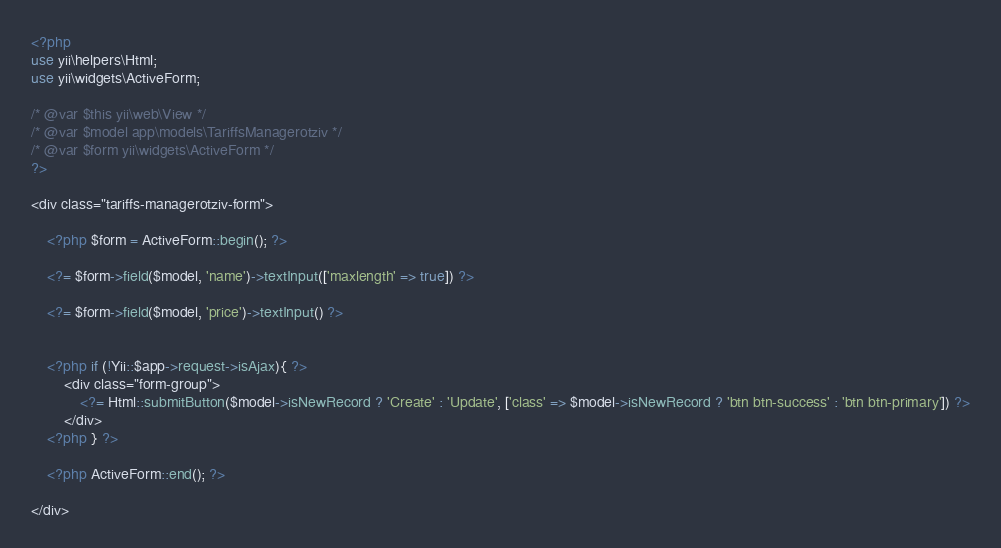Convert code to text. <code><loc_0><loc_0><loc_500><loc_500><_PHP_><?php
use yii\helpers\Html;
use yii\widgets\ActiveForm;

/* @var $this yii\web\View */
/* @var $model app\models\TariffsManagerotziv */
/* @var $form yii\widgets\ActiveForm */
?>

<div class="tariffs-managerotziv-form">

    <?php $form = ActiveForm::begin(); ?>

    <?= $form->field($model, 'name')->textInput(['maxlength' => true]) ?>

    <?= $form->field($model, 'price')->textInput() ?>

  
	<?php if (!Yii::$app->request->isAjax){ ?>
	  	<div class="form-group">
	        <?= Html::submitButton($model->isNewRecord ? 'Create' : 'Update', ['class' => $model->isNewRecord ? 'btn btn-success' : 'btn btn-primary']) ?>
	    </div>
	<?php } ?>

    <?php ActiveForm::end(); ?>
    
</div>
</code> 